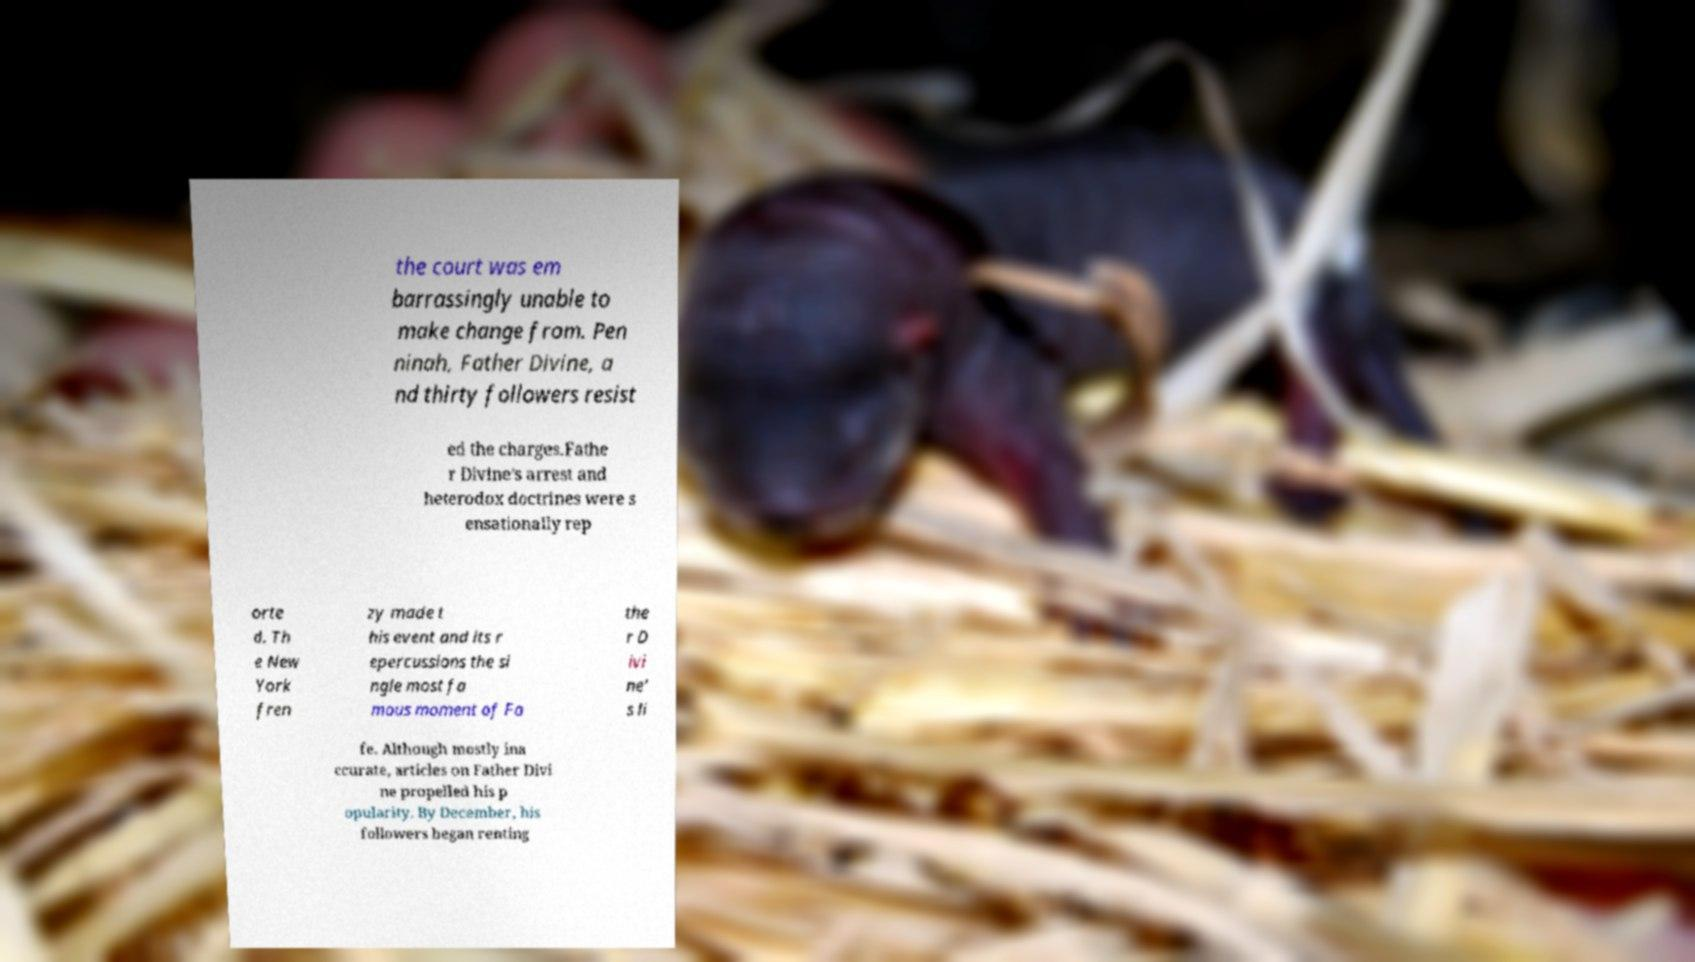Can you read and provide the text displayed in the image?This photo seems to have some interesting text. Can you extract and type it out for me? the court was em barrassingly unable to make change from. Pen ninah, Father Divine, a nd thirty followers resist ed the charges.Fathe r Divine's arrest and heterodox doctrines were s ensationally rep orte d. Th e New York fren zy made t his event and its r epercussions the si ngle most fa mous moment of Fa the r D ivi ne' s li fe. Although mostly ina ccurate, articles on Father Divi ne propelled his p opularity. By December, his followers began renting 